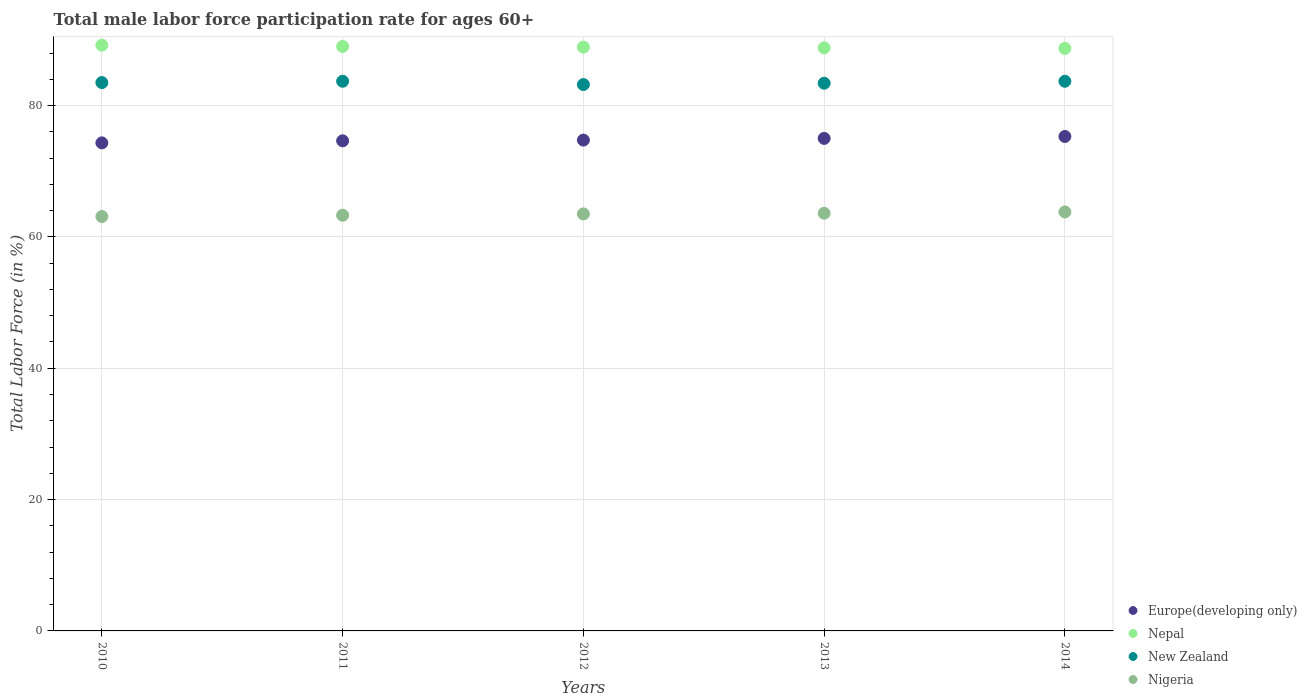How many different coloured dotlines are there?
Your answer should be compact. 4. What is the male labor force participation rate in New Zealand in 2014?
Your answer should be very brief. 83.7. Across all years, what is the maximum male labor force participation rate in Europe(developing only)?
Provide a succinct answer. 75.29. Across all years, what is the minimum male labor force participation rate in New Zealand?
Offer a very short reply. 83.2. In which year was the male labor force participation rate in Nepal maximum?
Offer a very short reply. 2010. What is the total male labor force participation rate in New Zealand in the graph?
Keep it short and to the point. 417.5. What is the difference between the male labor force participation rate in Nigeria in 2012 and that in 2014?
Your response must be concise. -0.3. What is the difference between the male labor force participation rate in Nigeria in 2013 and the male labor force participation rate in Europe(developing only) in 2010?
Provide a succinct answer. -10.72. What is the average male labor force participation rate in Nepal per year?
Provide a succinct answer. 88.92. In the year 2013, what is the difference between the male labor force participation rate in Nepal and male labor force participation rate in Nigeria?
Give a very brief answer. 25.2. What is the ratio of the male labor force participation rate in Nigeria in 2010 to that in 2011?
Your response must be concise. 1. What is the difference between the highest and the second highest male labor force participation rate in Europe(developing only)?
Your response must be concise. 0.29. In how many years, is the male labor force participation rate in New Zealand greater than the average male labor force participation rate in New Zealand taken over all years?
Provide a short and direct response. 3. Is the sum of the male labor force participation rate in New Zealand in 2011 and 2014 greater than the maximum male labor force participation rate in Europe(developing only) across all years?
Give a very brief answer. Yes. Is it the case that in every year, the sum of the male labor force participation rate in Nepal and male labor force participation rate in Europe(developing only)  is greater than the sum of male labor force participation rate in New Zealand and male labor force participation rate in Nigeria?
Provide a succinct answer. Yes. Does the male labor force participation rate in New Zealand monotonically increase over the years?
Ensure brevity in your answer.  No. Is the male labor force participation rate in Nigeria strictly greater than the male labor force participation rate in Europe(developing only) over the years?
Provide a succinct answer. No. Is the male labor force participation rate in Nigeria strictly less than the male labor force participation rate in Nepal over the years?
Give a very brief answer. Yes. How many dotlines are there?
Ensure brevity in your answer.  4. What is the difference between two consecutive major ticks on the Y-axis?
Your answer should be compact. 20. Where does the legend appear in the graph?
Offer a terse response. Bottom right. How are the legend labels stacked?
Your answer should be compact. Vertical. What is the title of the graph?
Offer a terse response. Total male labor force participation rate for ages 60+. What is the label or title of the X-axis?
Your answer should be very brief. Years. What is the Total Labor Force (in %) in Europe(developing only) in 2010?
Offer a very short reply. 74.32. What is the Total Labor Force (in %) of Nepal in 2010?
Give a very brief answer. 89.2. What is the Total Labor Force (in %) of New Zealand in 2010?
Give a very brief answer. 83.5. What is the Total Labor Force (in %) in Nigeria in 2010?
Provide a succinct answer. 63.1. What is the Total Labor Force (in %) in Europe(developing only) in 2011?
Offer a very short reply. 74.63. What is the Total Labor Force (in %) in Nepal in 2011?
Give a very brief answer. 89. What is the Total Labor Force (in %) of New Zealand in 2011?
Offer a very short reply. 83.7. What is the Total Labor Force (in %) of Nigeria in 2011?
Keep it short and to the point. 63.3. What is the Total Labor Force (in %) in Europe(developing only) in 2012?
Your answer should be compact. 74.74. What is the Total Labor Force (in %) in Nepal in 2012?
Your answer should be compact. 88.9. What is the Total Labor Force (in %) of New Zealand in 2012?
Provide a short and direct response. 83.2. What is the Total Labor Force (in %) of Nigeria in 2012?
Provide a succinct answer. 63.5. What is the Total Labor Force (in %) of Europe(developing only) in 2013?
Keep it short and to the point. 75. What is the Total Labor Force (in %) in Nepal in 2013?
Ensure brevity in your answer.  88.8. What is the Total Labor Force (in %) in New Zealand in 2013?
Your answer should be very brief. 83.4. What is the Total Labor Force (in %) of Nigeria in 2013?
Ensure brevity in your answer.  63.6. What is the Total Labor Force (in %) in Europe(developing only) in 2014?
Offer a very short reply. 75.29. What is the Total Labor Force (in %) of Nepal in 2014?
Offer a terse response. 88.7. What is the Total Labor Force (in %) in New Zealand in 2014?
Your answer should be compact. 83.7. What is the Total Labor Force (in %) of Nigeria in 2014?
Your answer should be very brief. 63.8. Across all years, what is the maximum Total Labor Force (in %) of Europe(developing only)?
Give a very brief answer. 75.29. Across all years, what is the maximum Total Labor Force (in %) of Nepal?
Offer a very short reply. 89.2. Across all years, what is the maximum Total Labor Force (in %) of New Zealand?
Make the answer very short. 83.7. Across all years, what is the maximum Total Labor Force (in %) in Nigeria?
Make the answer very short. 63.8. Across all years, what is the minimum Total Labor Force (in %) in Europe(developing only)?
Give a very brief answer. 74.32. Across all years, what is the minimum Total Labor Force (in %) of Nepal?
Make the answer very short. 88.7. Across all years, what is the minimum Total Labor Force (in %) in New Zealand?
Keep it short and to the point. 83.2. Across all years, what is the minimum Total Labor Force (in %) of Nigeria?
Provide a succinct answer. 63.1. What is the total Total Labor Force (in %) of Europe(developing only) in the graph?
Provide a short and direct response. 373.98. What is the total Total Labor Force (in %) of Nepal in the graph?
Make the answer very short. 444.6. What is the total Total Labor Force (in %) of New Zealand in the graph?
Provide a succinct answer. 417.5. What is the total Total Labor Force (in %) of Nigeria in the graph?
Keep it short and to the point. 317.3. What is the difference between the Total Labor Force (in %) of Europe(developing only) in 2010 and that in 2011?
Make the answer very short. -0.31. What is the difference between the Total Labor Force (in %) in New Zealand in 2010 and that in 2011?
Ensure brevity in your answer.  -0.2. What is the difference between the Total Labor Force (in %) in Europe(developing only) in 2010 and that in 2012?
Offer a very short reply. -0.42. What is the difference between the Total Labor Force (in %) of New Zealand in 2010 and that in 2012?
Ensure brevity in your answer.  0.3. What is the difference between the Total Labor Force (in %) of Nigeria in 2010 and that in 2012?
Offer a very short reply. -0.4. What is the difference between the Total Labor Force (in %) of Europe(developing only) in 2010 and that in 2013?
Your answer should be compact. -0.68. What is the difference between the Total Labor Force (in %) of Europe(developing only) in 2010 and that in 2014?
Your response must be concise. -0.97. What is the difference between the Total Labor Force (in %) of New Zealand in 2010 and that in 2014?
Keep it short and to the point. -0.2. What is the difference between the Total Labor Force (in %) in Nigeria in 2010 and that in 2014?
Ensure brevity in your answer.  -0.7. What is the difference between the Total Labor Force (in %) in Europe(developing only) in 2011 and that in 2012?
Your response must be concise. -0.11. What is the difference between the Total Labor Force (in %) in Europe(developing only) in 2011 and that in 2013?
Ensure brevity in your answer.  -0.37. What is the difference between the Total Labor Force (in %) of Europe(developing only) in 2011 and that in 2014?
Offer a terse response. -0.66. What is the difference between the Total Labor Force (in %) in Nepal in 2011 and that in 2014?
Your answer should be compact. 0.3. What is the difference between the Total Labor Force (in %) of Europe(developing only) in 2012 and that in 2013?
Offer a very short reply. -0.26. What is the difference between the Total Labor Force (in %) of Nigeria in 2012 and that in 2013?
Your answer should be compact. -0.1. What is the difference between the Total Labor Force (in %) of Europe(developing only) in 2012 and that in 2014?
Make the answer very short. -0.55. What is the difference between the Total Labor Force (in %) of Nigeria in 2012 and that in 2014?
Your answer should be compact. -0.3. What is the difference between the Total Labor Force (in %) of Europe(developing only) in 2013 and that in 2014?
Your answer should be very brief. -0.29. What is the difference between the Total Labor Force (in %) in Nepal in 2013 and that in 2014?
Provide a short and direct response. 0.1. What is the difference between the Total Labor Force (in %) of Nigeria in 2013 and that in 2014?
Keep it short and to the point. -0.2. What is the difference between the Total Labor Force (in %) in Europe(developing only) in 2010 and the Total Labor Force (in %) in Nepal in 2011?
Offer a terse response. -14.68. What is the difference between the Total Labor Force (in %) of Europe(developing only) in 2010 and the Total Labor Force (in %) of New Zealand in 2011?
Provide a succinct answer. -9.38. What is the difference between the Total Labor Force (in %) in Europe(developing only) in 2010 and the Total Labor Force (in %) in Nigeria in 2011?
Offer a terse response. 11.02. What is the difference between the Total Labor Force (in %) in Nepal in 2010 and the Total Labor Force (in %) in New Zealand in 2011?
Keep it short and to the point. 5.5. What is the difference between the Total Labor Force (in %) of Nepal in 2010 and the Total Labor Force (in %) of Nigeria in 2011?
Your answer should be compact. 25.9. What is the difference between the Total Labor Force (in %) in New Zealand in 2010 and the Total Labor Force (in %) in Nigeria in 2011?
Provide a succinct answer. 20.2. What is the difference between the Total Labor Force (in %) in Europe(developing only) in 2010 and the Total Labor Force (in %) in Nepal in 2012?
Offer a terse response. -14.58. What is the difference between the Total Labor Force (in %) in Europe(developing only) in 2010 and the Total Labor Force (in %) in New Zealand in 2012?
Offer a very short reply. -8.88. What is the difference between the Total Labor Force (in %) in Europe(developing only) in 2010 and the Total Labor Force (in %) in Nigeria in 2012?
Offer a very short reply. 10.82. What is the difference between the Total Labor Force (in %) of Nepal in 2010 and the Total Labor Force (in %) of Nigeria in 2012?
Ensure brevity in your answer.  25.7. What is the difference between the Total Labor Force (in %) of New Zealand in 2010 and the Total Labor Force (in %) of Nigeria in 2012?
Your response must be concise. 20. What is the difference between the Total Labor Force (in %) in Europe(developing only) in 2010 and the Total Labor Force (in %) in Nepal in 2013?
Your answer should be compact. -14.48. What is the difference between the Total Labor Force (in %) of Europe(developing only) in 2010 and the Total Labor Force (in %) of New Zealand in 2013?
Provide a short and direct response. -9.08. What is the difference between the Total Labor Force (in %) in Europe(developing only) in 2010 and the Total Labor Force (in %) in Nigeria in 2013?
Ensure brevity in your answer.  10.72. What is the difference between the Total Labor Force (in %) in Nepal in 2010 and the Total Labor Force (in %) in New Zealand in 2013?
Your response must be concise. 5.8. What is the difference between the Total Labor Force (in %) of Nepal in 2010 and the Total Labor Force (in %) of Nigeria in 2013?
Your answer should be very brief. 25.6. What is the difference between the Total Labor Force (in %) of New Zealand in 2010 and the Total Labor Force (in %) of Nigeria in 2013?
Keep it short and to the point. 19.9. What is the difference between the Total Labor Force (in %) of Europe(developing only) in 2010 and the Total Labor Force (in %) of Nepal in 2014?
Keep it short and to the point. -14.38. What is the difference between the Total Labor Force (in %) of Europe(developing only) in 2010 and the Total Labor Force (in %) of New Zealand in 2014?
Offer a very short reply. -9.38. What is the difference between the Total Labor Force (in %) of Europe(developing only) in 2010 and the Total Labor Force (in %) of Nigeria in 2014?
Give a very brief answer. 10.52. What is the difference between the Total Labor Force (in %) of Nepal in 2010 and the Total Labor Force (in %) of New Zealand in 2014?
Offer a terse response. 5.5. What is the difference between the Total Labor Force (in %) in Nepal in 2010 and the Total Labor Force (in %) in Nigeria in 2014?
Provide a succinct answer. 25.4. What is the difference between the Total Labor Force (in %) in New Zealand in 2010 and the Total Labor Force (in %) in Nigeria in 2014?
Your response must be concise. 19.7. What is the difference between the Total Labor Force (in %) of Europe(developing only) in 2011 and the Total Labor Force (in %) of Nepal in 2012?
Ensure brevity in your answer.  -14.27. What is the difference between the Total Labor Force (in %) of Europe(developing only) in 2011 and the Total Labor Force (in %) of New Zealand in 2012?
Offer a terse response. -8.57. What is the difference between the Total Labor Force (in %) in Europe(developing only) in 2011 and the Total Labor Force (in %) in Nigeria in 2012?
Give a very brief answer. 11.13. What is the difference between the Total Labor Force (in %) in Nepal in 2011 and the Total Labor Force (in %) in New Zealand in 2012?
Offer a very short reply. 5.8. What is the difference between the Total Labor Force (in %) of New Zealand in 2011 and the Total Labor Force (in %) of Nigeria in 2012?
Provide a succinct answer. 20.2. What is the difference between the Total Labor Force (in %) in Europe(developing only) in 2011 and the Total Labor Force (in %) in Nepal in 2013?
Give a very brief answer. -14.17. What is the difference between the Total Labor Force (in %) in Europe(developing only) in 2011 and the Total Labor Force (in %) in New Zealand in 2013?
Provide a short and direct response. -8.77. What is the difference between the Total Labor Force (in %) of Europe(developing only) in 2011 and the Total Labor Force (in %) of Nigeria in 2013?
Your answer should be very brief. 11.03. What is the difference between the Total Labor Force (in %) in Nepal in 2011 and the Total Labor Force (in %) in Nigeria in 2013?
Give a very brief answer. 25.4. What is the difference between the Total Labor Force (in %) in New Zealand in 2011 and the Total Labor Force (in %) in Nigeria in 2013?
Keep it short and to the point. 20.1. What is the difference between the Total Labor Force (in %) in Europe(developing only) in 2011 and the Total Labor Force (in %) in Nepal in 2014?
Ensure brevity in your answer.  -14.07. What is the difference between the Total Labor Force (in %) in Europe(developing only) in 2011 and the Total Labor Force (in %) in New Zealand in 2014?
Offer a terse response. -9.07. What is the difference between the Total Labor Force (in %) of Europe(developing only) in 2011 and the Total Labor Force (in %) of Nigeria in 2014?
Make the answer very short. 10.83. What is the difference between the Total Labor Force (in %) in Nepal in 2011 and the Total Labor Force (in %) in New Zealand in 2014?
Offer a very short reply. 5.3. What is the difference between the Total Labor Force (in %) in Nepal in 2011 and the Total Labor Force (in %) in Nigeria in 2014?
Your answer should be compact. 25.2. What is the difference between the Total Labor Force (in %) in New Zealand in 2011 and the Total Labor Force (in %) in Nigeria in 2014?
Ensure brevity in your answer.  19.9. What is the difference between the Total Labor Force (in %) of Europe(developing only) in 2012 and the Total Labor Force (in %) of Nepal in 2013?
Give a very brief answer. -14.06. What is the difference between the Total Labor Force (in %) in Europe(developing only) in 2012 and the Total Labor Force (in %) in New Zealand in 2013?
Keep it short and to the point. -8.66. What is the difference between the Total Labor Force (in %) in Europe(developing only) in 2012 and the Total Labor Force (in %) in Nigeria in 2013?
Offer a terse response. 11.14. What is the difference between the Total Labor Force (in %) of Nepal in 2012 and the Total Labor Force (in %) of New Zealand in 2013?
Your answer should be compact. 5.5. What is the difference between the Total Labor Force (in %) of Nepal in 2012 and the Total Labor Force (in %) of Nigeria in 2013?
Your answer should be compact. 25.3. What is the difference between the Total Labor Force (in %) of New Zealand in 2012 and the Total Labor Force (in %) of Nigeria in 2013?
Give a very brief answer. 19.6. What is the difference between the Total Labor Force (in %) in Europe(developing only) in 2012 and the Total Labor Force (in %) in Nepal in 2014?
Make the answer very short. -13.96. What is the difference between the Total Labor Force (in %) in Europe(developing only) in 2012 and the Total Labor Force (in %) in New Zealand in 2014?
Ensure brevity in your answer.  -8.96. What is the difference between the Total Labor Force (in %) of Europe(developing only) in 2012 and the Total Labor Force (in %) of Nigeria in 2014?
Give a very brief answer. 10.94. What is the difference between the Total Labor Force (in %) of Nepal in 2012 and the Total Labor Force (in %) of Nigeria in 2014?
Offer a very short reply. 25.1. What is the difference between the Total Labor Force (in %) in Europe(developing only) in 2013 and the Total Labor Force (in %) in Nepal in 2014?
Your answer should be very brief. -13.7. What is the difference between the Total Labor Force (in %) of Europe(developing only) in 2013 and the Total Labor Force (in %) of New Zealand in 2014?
Provide a succinct answer. -8.7. What is the difference between the Total Labor Force (in %) of Europe(developing only) in 2013 and the Total Labor Force (in %) of Nigeria in 2014?
Offer a very short reply. 11.2. What is the difference between the Total Labor Force (in %) of Nepal in 2013 and the Total Labor Force (in %) of Nigeria in 2014?
Your response must be concise. 25. What is the difference between the Total Labor Force (in %) in New Zealand in 2013 and the Total Labor Force (in %) in Nigeria in 2014?
Provide a succinct answer. 19.6. What is the average Total Labor Force (in %) in Europe(developing only) per year?
Make the answer very short. 74.8. What is the average Total Labor Force (in %) of Nepal per year?
Your answer should be compact. 88.92. What is the average Total Labor Force (in %) of New Zealand per year?
Offer a very short reply. 83.5. What is the average Total Labor Force (in %) of Nigeria per year?
Ensure brevity in your answer.  63.46. In the year 2010, what is the difference between the Total Labor Force (in %) of Europe(developing only) and Total Labor Force (in %) of Nepal?
Provide a short and direct response. -14.88. In the year 2010, what is the difference between the Total Labor Force (in %) in Europe(developing only) and Total Labor Force (in %) in New Zealand?
Give a very brief answer. -9.18. In the year 2010, what is the difference between the Total Labor Force (in %) of Europe(developing only) and Total Labor Force (in %) of Nigeria?
Your answer should be very brief. 11.22. In the year 2010, what is the difference between the Total Labor Force (in %) in Nepal and Total Labor Force (in %) in Nigeria?
Provide a short and direct response. 26.1. In the year 2010, what is the difference between the Total Labor Force (in %) in New Zealand and Total Labor Force (in %) in Nigeria?
Give a very brief answer. 20.4. In the year 2011, what is the difference between the Total Labor Force (in %) of Europe(developing only) and Total Labor Force (in %) of Nepal?
Your response must be concise. -14.37. In the year 2011, what is the difference between the Total Labor Force (in %) in Europe(developing only) and Total Labor Force (in %) in New Zealand?
Your answer should be very brief. -9.07. In the year 2011, what is the difference between the Total Labor Force (in %) of Europe(developing only) and Total Labor Force (in %) of Nigeria?
Your answer should be very brief. 11.33. In the year 2011, what is the difference between the Total Labor Force (in %) of Nepal and Total Labor Force (in %) of Nigeria?
Provide a succinct answer. 25.7. In the year 2011, what is the difference between the Total Labor Force (in %) of New Zealand and Total Labor Force (in %) of Nigeria?
Ensure brevity in your answer.  20.4. In the year 2012, what is the difference between the Total Labor Force (in %) of Europe(developing only) and Total Labor Force (in %) of Nepal?
Provide a short and direct response. -14.16. In the year 2012, what is the difference between the Total Labor Force (in %) of Europe(developing only) and Total Labor Force (in %) of New Zealand?
Offer a terse response. -8.46. In the year 2012, what is the difference between the Total Labor Force (in %) of Europe(developing only) and Total Labor Force (in %) of Nigeria?
Keep it short and to the point. 11.24. In the year 2012, what is the difference between the Total Labor Force (in %) in Nepal and Total Labor Force (in %) in New Zealand?
Give a very brief answer. 5.7. In the year 2012, what is the difference between the Total Labor Force (in %) of Nepal and Total Labor Force (in %) of Nigeria?
Provide a short and direct response. 25.4. In the year 2012, what is the difference between the Total Labor Force (in %) in New Zealand and Total Labor Force (in %) in Nigeria?
Keep it short and to the point. 19.7. In the year 2013, what is the difference between the Total Labor Force (in %) of Europe(developing only) and Total Labor Force (in %) of Nepal?
Offer a very short reply. -13.8. In the year 2013, what is the difference between the Total Labor Force (in %) of Europe(developing only) and Total Labor Force (in %) of New Zealand?
Provide a succinct answer. -8.4. In the year 2013, what is the difference between the Total Labor Force (in %) in Europe(developing only) and Total Labor Force (in %) in Nigeria?
Make the answer very short. 11.4. In the year 2013, what is the difference between the Total Labor Force (in %) in Nepal and Total Labor Force (in %) in Nigeria?
Provide a short and direct response. 25.2. In the year 2013, what is the difference between the Total Labor Force (in %) in New Zealand and Total Labor Force (in %) in Nigeria?
Ensure brevity in your answer.  19.8. In the year 2014, what is the difference between the Total Labor Force (in %) of Europe(developing only) and Total Labor Force (in %) of Nepal?
Provide a short and direct response. -13.41. In the year 2014, what is the difference between the Total Labor Force (in %) of Europe(developing only) and Total Labor Force (in %) of New Zealand?
Offer a terse response. -8.41. In the year 2014, what is the difference between the Total Labor Force (in %) in Europe(developing only) and Total Labor Force (in %) in Nigeria?
Offer a terse response. 11.49. In the year 2014, what is the difference between the Total Labor Force (in %) in Nepal and Total Labor Force (in %) in Nigeria?
Make the answer very short. 24.9. In the year 2014, what is the difference between the Total Labor Force (in %) in New Zealand and Total Labor Force (in %) in Nigeria?
Your response must be concise. 19.9. What is the ratio of the Total Labor Force (in %) of Nepal in 2010 to that in 2011?
Give a very brief answer. 1. What is the ratio of the Total Labor Force (in %) of Nigeria in 2010 to that in 2011?
Ensure brevity in your answer.  1. What is the ratio of the Total Labor Force (in %) in Europe(developing only) in 2010 to that in 2013?
Provide a succinct answer. 0.99. What is the ratio of the Total Labor Force (in %) of Europe(developing only) in 2010 to that in 2014?
Offer a very short reply. 0.99. What is the ratio of the Total Labor Force (in %) in Nepal in 2010 to that in 2014?
Make the answer very short. 1.01. What is the ratio of the Total Labor Force (in %) in Nigeria in 2010 to that in 2014?
Your answer should be compact. 0.99. What is the ratio of the Total Labor Force (in %) of Europe(developing only) in 2011 to that in 2012?
Offer a terse response. 1. What is the ratio of the Total Labor Force (in %) in New Zealand in 2011 to that in 2012?
Offer a terse response. 1.01. What is the ratio of the Total Labor Force (in %) in Nepal in 2011 to that in 2013?
Your response must be concise. 1. What is the ratio of the Total Labor Force (in %) of Nigeria in 2011 to that in 2013?
Provide a short and direct response. 1. What is the ratio of the Total Labor Force (in %) of Europe(developing only) in 2011 to that in 2014?
Offer a terse response. 0.99. What is the ratio of the Total Labor Force (in %) of Nepal in 2011 to that in 2014?
Make the answer very short. 1. What is the ratio of the Total Labor Force (in %) in New Zealand in 2012 to that in 2013?
Make the answer very short. 1. What is the ratio of the Total Labor Force (in %) of Nigeria in 2012 to that in 2013?
Offer a very short reply. 1. What is the ratio of the Total Labor Force (in %) of Nepal in 2012 to that in 2014?
Offer a very short reply. 1. What is the ratio of the Total Labor Force (in %) in New Zealand in 2012 to that in 2014?
Your response must be concise. 0.99. What is the ratio of the Total Labor Force (in %) of Nigeria in 2012 to that in 2014?
Offer a very short reply. 1. What is the ratio of the Total Labor Force (in %) of New Zealand in 2013 to that in 2014?
Keep it short and to the point. 1. What is the difference between the highest and the second highest Total Labor Force (in %) of Europe(developing only)?
Your answer should be very brief. 0.29. What is the difference between the highest and the second highest Total Labor Force (in %) of Nepal?
Provide a short and direct response. 0.2. What is the difference between the highest and the second highest Total Labor Force (in %) in New Zealand?
Offer a very short reply. 0. What is the difference between the highest and the lowest Total Labor Force (in %) of Europe(developing only)?
Your answer should be very brief. 0.97. What is the difference between the highest and the lowest Total Labor Force (in %) of Nepal?
Ensure brevity in your answer.  0.5. 